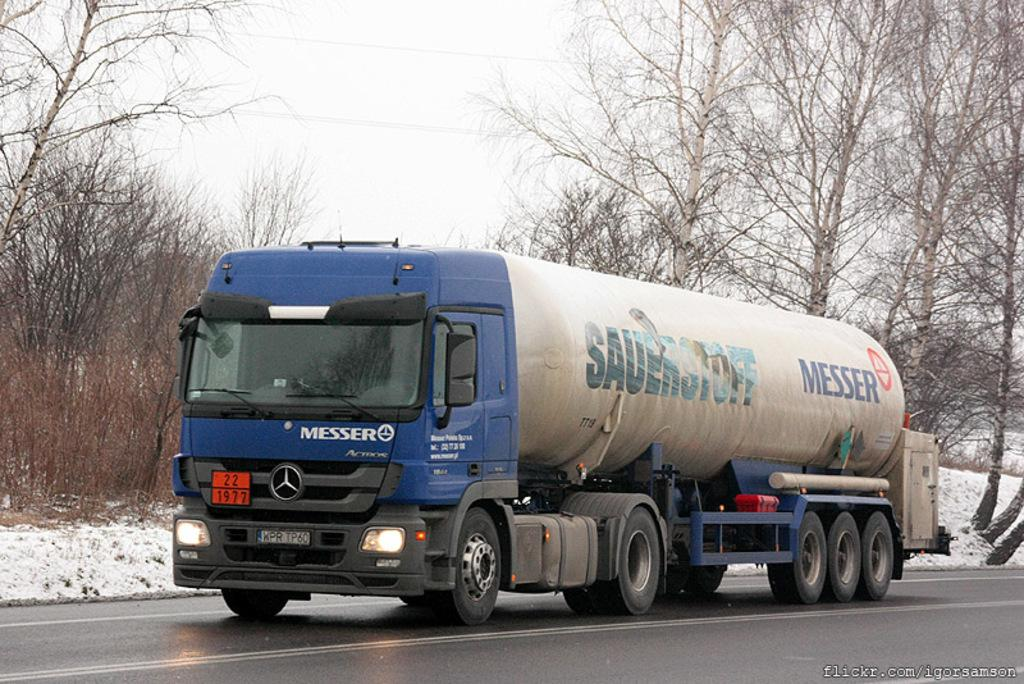What type of vehicle is on the road in the image? There is a truck on the road in the image. What natural elements can be seen in the image? There is a group of trees and snow on the ground visible in the image. What man-made structures are present in the image? Wires are present in the image. How would you describe the weather in the image? The sky appears cloudy in the image. How does the afterthought join the attention in the image? There is no afterthought or attention present in the image; it only features a truck, trees, wires, snow, and a cloudy sky. 